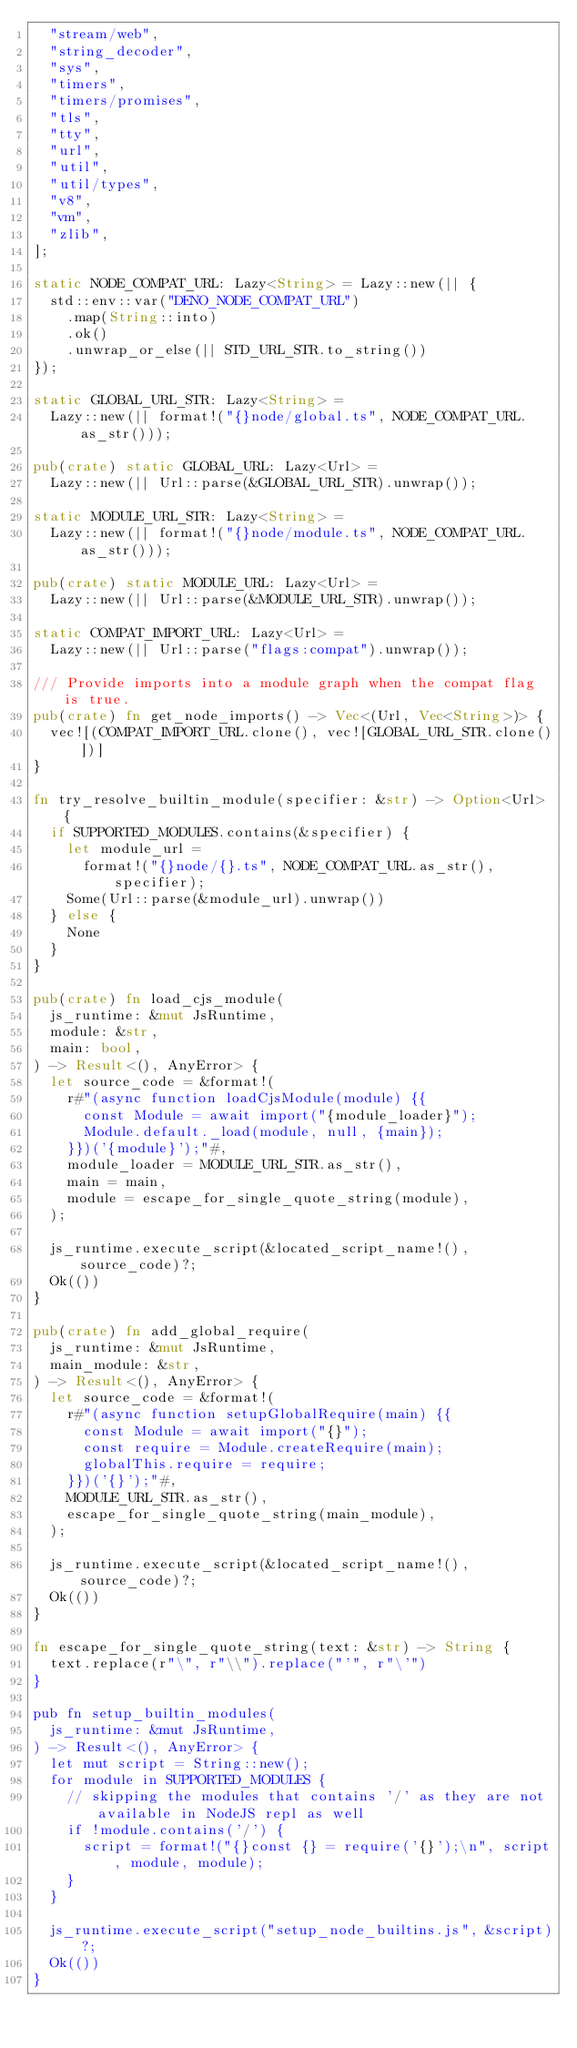<code> <loc_0><loc_0><loc_500><loc_500><_Rust_>  "stream/web",
  "string_decoder",
  "sys",
  "timers",
  "timers/promises",
  "tls",
  "tty",
  "url",
  "util",
  "util/types",
  "v8",
  "vm",
  "zlib",
];

static NODE_COMPAT_URL: Lazy<String> = Lazy::new(|| {
  std::env::var("DENO_NODE_COMPAT_URL")
    .map(String::into)
    .ok()
    .unwrap_or_else(|| STD_URL_STR.to_string())
});

static GLOBAL_URL_STR: Lazy<String> =
  Lazy::new(|| format!("{}node/global.ts", NODE_COMPAT_URL.as_str()));

pub(crate) static GLOBAL_URL: Lazy<Url> =
  Lazy::new(|| Url::parse(&GLOBAL_URL_STR).unwrap());

static MODULE_URL_STR: Lazy<String> =
  Lazy::new(|| format!("{}node/module.ts", NODE_COMPAT_URL.as_str()));

pub(crate) static MODULE_URL: Lazy<Url> =
  Lazy::new(|| Url::parse(&MODULE_URL_STR).unwrap());

static COMPAT_IMPORT_URL: Lazy<Url> =
  Lazy::new(|| Url::parse("flags:compat").unwrap());

/// Provide imports into a module graph when the compat flag is true.
pub(crate) fn get_node_imports() -> Vec<(Url, Vec<String>)> {
  vec![(COMPAT_IMPORT_URL.clone(), vec![GLOBAL_URL_STR.clone()])]
}

fn try_resolve_builtin_module(specifier: &str) -> Option<Url> {
  if SUPPORTED_MODULES.contains(&specifier) {
    let module_url =
      format!("{}node/{}.ts", NODE_COMPAT_URL.as_str(), specifier);
    Some(Url::parse(&module_url).unwrap())
  } else {
    None
  }
}

pub(crate) fn load_cjs_module(
  js_runtime: &mut JsRuntime,
  module: &str,
  main: bool,
) -> Result<(), AnyError> {
  let source_code = &format!(
    r#"(async function loadCjsModule(module) {{
      const Module = await import("{module_loader}");
      Module.default._load(module, null, {main});
    }})('{module}');"#,
    module_loader = MODULE_URL_STR.as_str(),
    main = main,
    module = escape_for_single_quote_string(module),
  );

  js_runtime.execute_script(&located_script_name!(), source_code)?;
  Ok(())
}

pub(crate) fn add_global_require(
  js_runtime: &mut JsRuntime,
  main_module: &str,
) -> Result<(), AnyError> {
  let source_code = &format!(
    r#"(async function setupGlobalRequire(main) {{
      const Module = await import("{}");
      const require = Module.createRequire(main);
      globalThis.require = require;
    }})('{}');"#,
    MODULE_URL_STR.as_str(),
    escape_for_single_quote_string(main_module),
  );

  js_runtime.execute_script(&located_script_name!(), source_code)?;
  Ok(())
}

fn escape_for_single_quote_string(text: &str) -> String {
  text.replace(r"\", r"\\").replace("'", r"\'")
}

pub fn setup_builtin_modules(
  js_runtime: &mut JsRuntime,
) -> Result<(), AnyError> {
  let mut script = String::new();
  for module in SUPPORTED_MODULES {
    // skipping the modules that contains '/' as they are not available in NodeJS repl as well
    if !module.contains('/') {
      script = format!("{}const {} = require('{}');\n", script, module, module);
    }
  }

  js_runtime.execute_script("setup_node_builtins.js", &script)?;
  Ok(())
}
</code> 